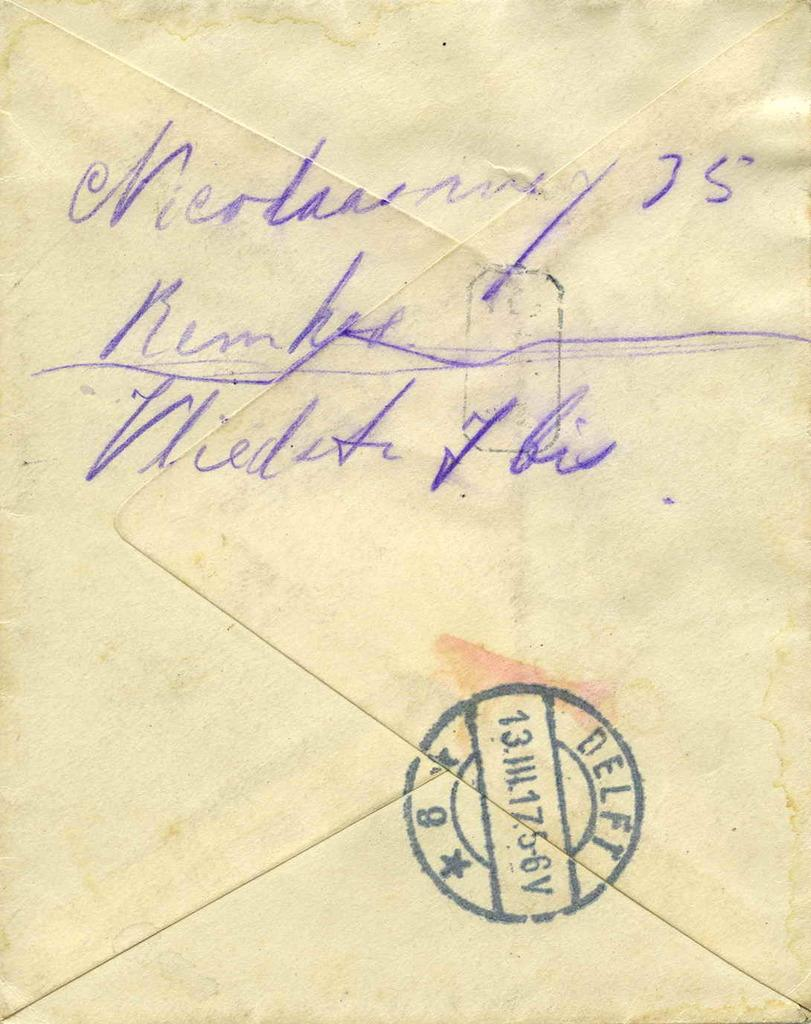<image>
Relay a brief, clear account of the picture shown. Letter with writing in cursive and a stamp that says "ELFT". 